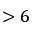Convert formula to latex. <formula><loc_0><loc_0><loc_500><loc_500>> 6</formula> 